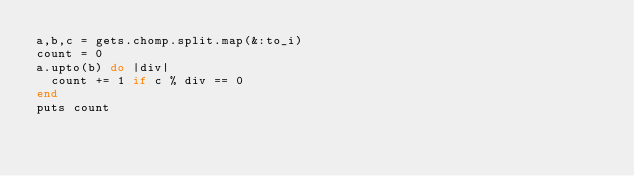Convert code to text. <code><loc_0><loc_0><loc_500><loc_500><_Ruby_>a,b,c = gets.chomp.split.map(&:to_i)
count = 0
a.upto(b) do |div|
  count += 1 if c % div == 0
end
puts count
</code> 